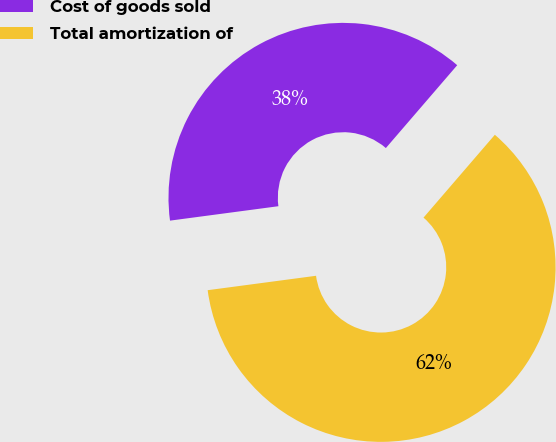Convert chart. <chart><loc_0><loc_0><loc_500><loc_500><pie_chart><fcel>Cost of goods sold<fcel>Total amortization of<nl><fcel>38.42%<fcel>61.58%<nl></chart> 